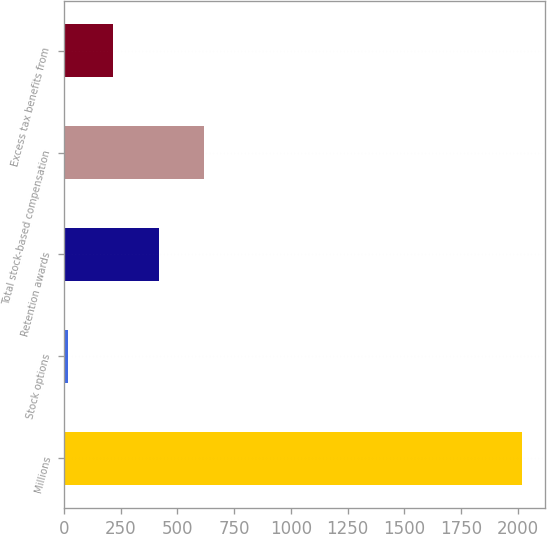Convert chart. <chart><loc_0><loc_0><loc_500><loc_500><bar_chart><fcel>Millions<fcel>Stock options<fcel>Retention awards<fcel>Total stock-based compensation<fcel>Excess tax benefits from<nl><fcel>2018<fcel>17<fcel>417.2<fcel>617.3<fcel>217.1<nl></chart> 